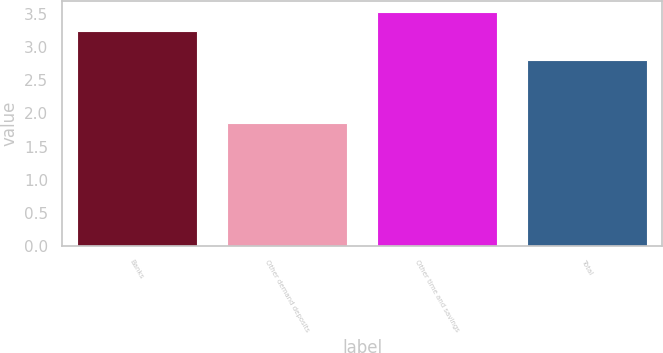Convert chart to OTSL. <chart><loc_0><loc_0><loc_500><loc_500><bar_chart><fcel>Banks<fcel>Other demand deposits<fcel>Other time and savings<fcel>Total<nl><fcel>3.25<fcel>1.85<fcel>3.53<fcel>2.81<nl></chart> 